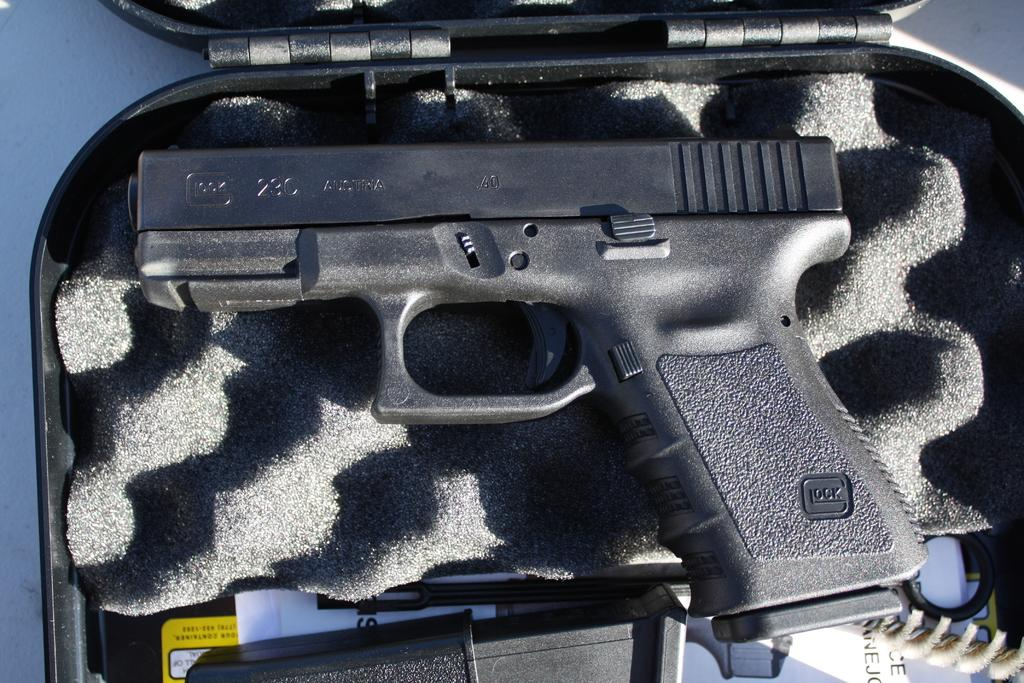What object is the main subject of the image? There is a gun in the image. Is there any specific accessory or container for the gun in the image? Yes, there is a box for the gun in the image. Can you tell me how many committee members are present at the lake in the image? There is no lake, committee members, or any reference to a lake or committee in the image. 